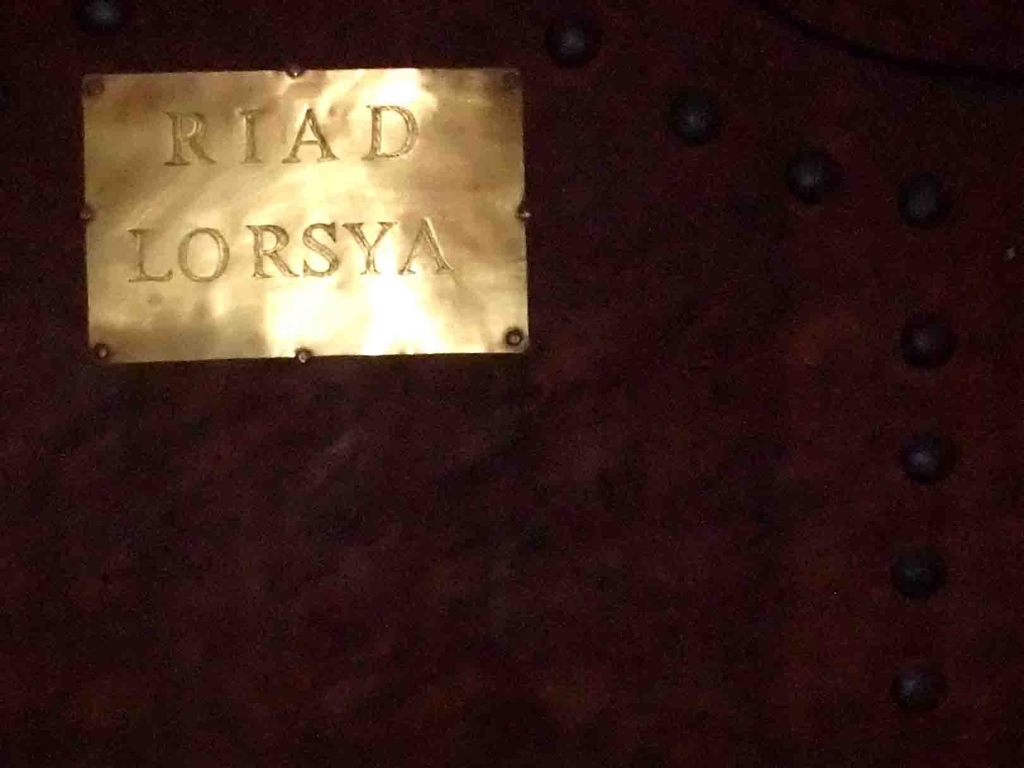Can you tell me more about what 'RIAD LORSYA' might signify? The term 'riad' typically refers to a traditional Moroccan house or palace with an interior garden or courtyard. 'LORSYA' is likely the specific name of such an establishment. This suggests that the sign is indicating the entrance to a riad named Lorsya, often characterized by its unique architecture and tranquil setting, offering an authentic Moroccan experience. 